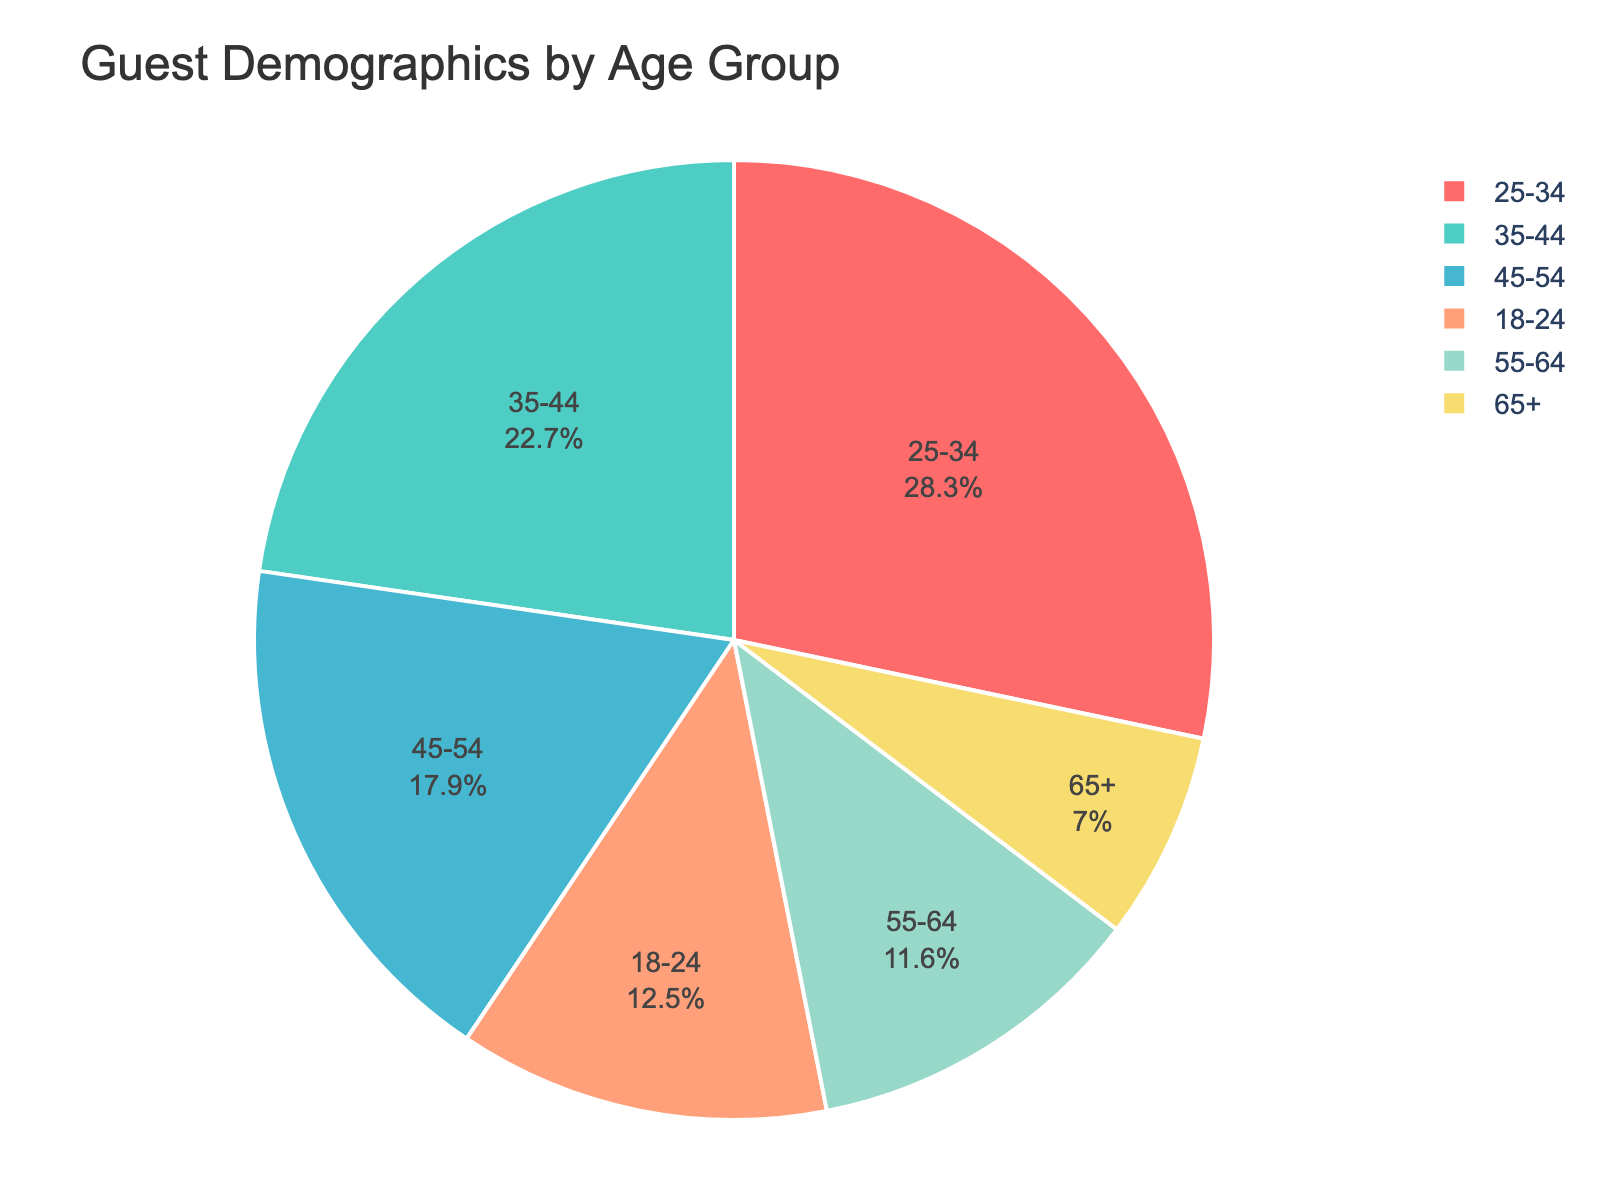Which age group has the highest percentage? The age group with the highest percentage can be identified by looking at the segment of the pie chart with the largest area. In the figure, the age group 25-34 has the largest segment, representing 28.3%.
Answer: 25-34 Which two age groups together make up more than half of the total guest demographics? To identify which two age groups together make up more than half of the guest demographics, sum the percentages and find pairs that exceed 50%. The age groups 25-34 (28.3%) and 35-44 (22.7%) together make up 51%, which is more than half.
Answer: 25-34 and 35-44 Which age group contributes the least to the guest demographics? The segment with the smallest area represents the age group with the least percentage. In the figure, the smallest segment corresponds to the 65+ age group with 7%.
Answer: 65+ How much greater is the percentage of the 25-34 age group compared to the 55-64 age group? Subtract the percentage of the 55-64 age group (11.6%) from the 25-34 age group (28.3%). The difference is 28.3% - 11.6% = 16.7%.
Answer: 16.7% What is the combined percentage of the age groups below 35? Sum the percentages of the age groups 18-24 and 25-34. The combined percentage is 12.5% + 28.3% = 40.8%.
Answer: 40.8% Which colors represent the 25-34 and 55-64 age groups respectively, and how can they be visually distinguished? In the figure, the 25-34 age group is represented by the second-largest segment, which is a greenish color. The 55-64 age group is represented by a smaller segment with a yellow color. These segments can be visually distinguished by their different sizes and corresponding colors.
Answer: Greenish for 25-34 and yellow for 55-64 If the 18-24 and 65+ age groups were combined into a single group, what would the new percentage be? Would it be larger or smaller than any other single current age group? Sum the percentages of the 18-24 (12.5%) and 65+ (7.0%) age groups to get 12.5% + 7.0% = 19.5%. This new combined percentage is larger than some groups like 55-64 (11.6%) and 45-54 (17.9%) , but smaller than 35-44 (22.7%) and 25-34 (28.3%).
Answer: 19.5%, larger than some and smaller than others 